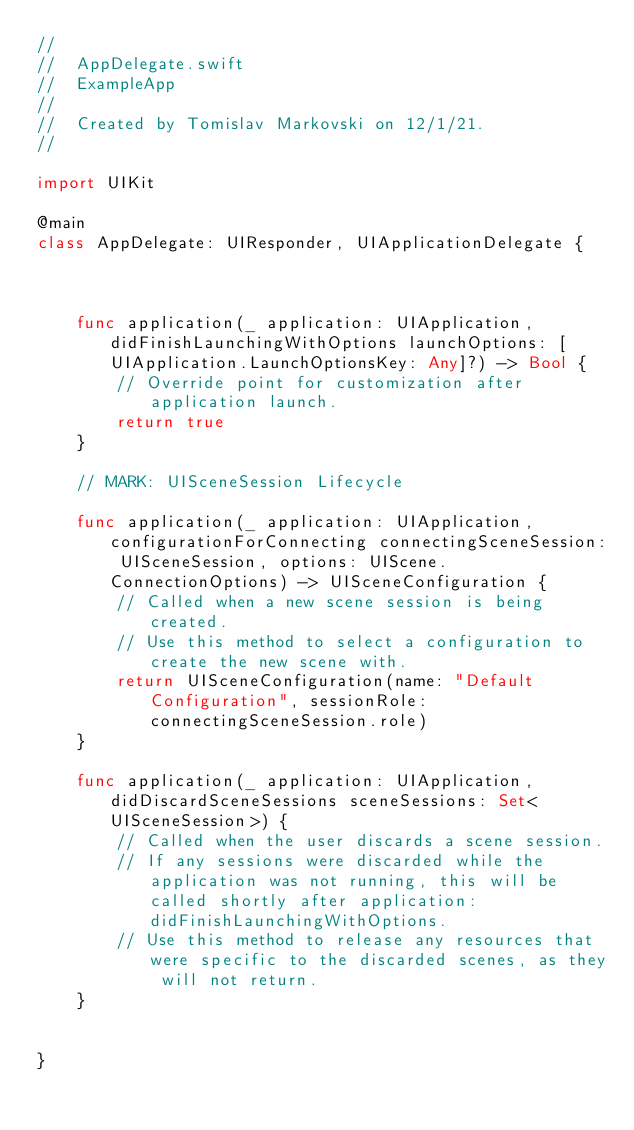<code> <loc_0><loc_0><loc_500><loc_500><_Swift_>//
//  AppDelegate.swift
//  ExampleApp
//
//  Created by Tomislav Markovski on 12/1/21.
//

import UIKit

@main
class AppDelegate: UIResponder, UIApplicationDelegate {



    func application(_ application: UIApplication, didFinishLaunchingWithOptions launchOptions: [UIApplication.LaunchOptionsKey: Any]?) -> Bool {
        // Override point for customization after application launch.
        return true
    }

    // MARK: UISceneSession Lifecycle

    func application(_ application: UIApplication, configurationForConnecting connectingSceneSession: UISceneSession, options: UIScene.ConnectionOptions) -> UISceneConfiguration {
        // Called when a new scene session is being created.
        // Use this method to select a configuration to create the new scene with.
        return UISceneConfiguration(name: "Default Configuration", sessionRole: connectingSceneSession.role)
    }

    func application(_ application: UIApplication, didDiscardSceneSessions sceneSessions: Set<UISceneSession>) {
        // Called when the user discards a scene session.
        // If any sessions were discarded while the application was not running, this will be called shortly after application:didFinishLaunchingWithOptions.
        // Use this method to release any resources that were specific to the discarded scenes, as they will not return.
    }


}

</code> 